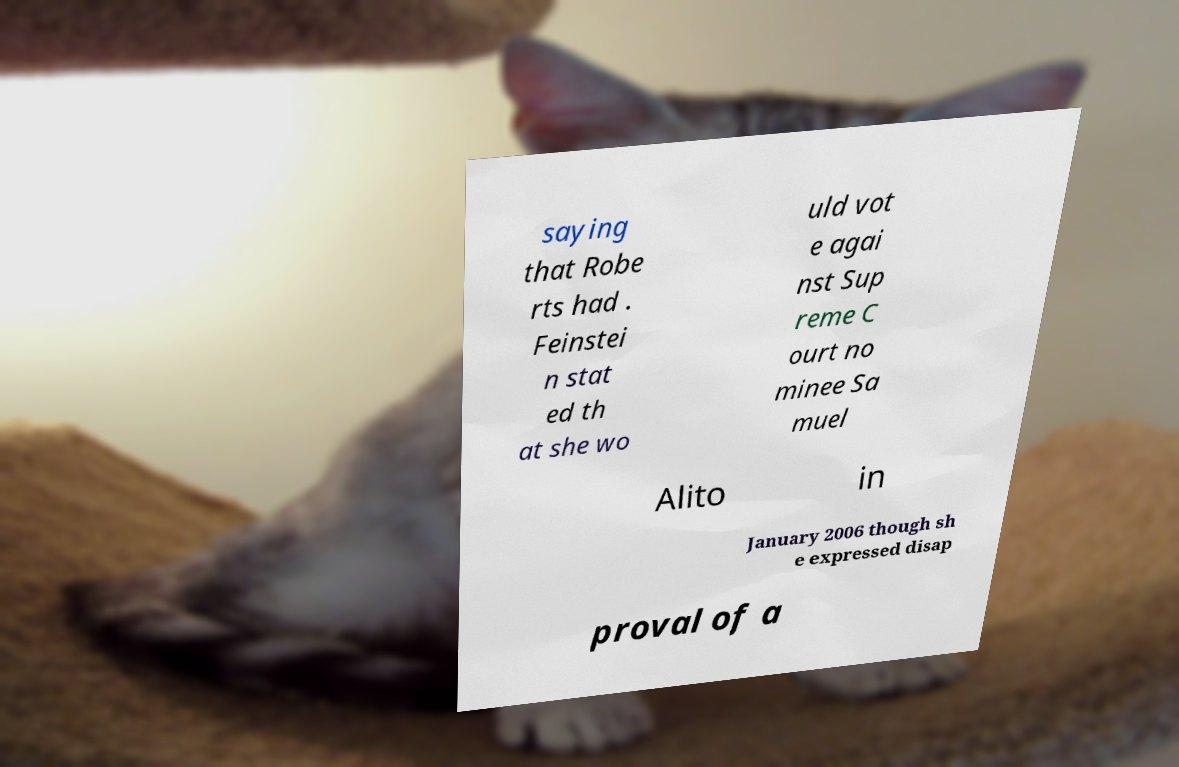I need the written content from this picture converted into text. Can you do that? saying that Robe rts had . Feinstei n stat ed th at she wo uld vot e agai nst Sup reme C ourt no minee Sa muel Alito in January 2006 though sh e expressed disap proval of a 